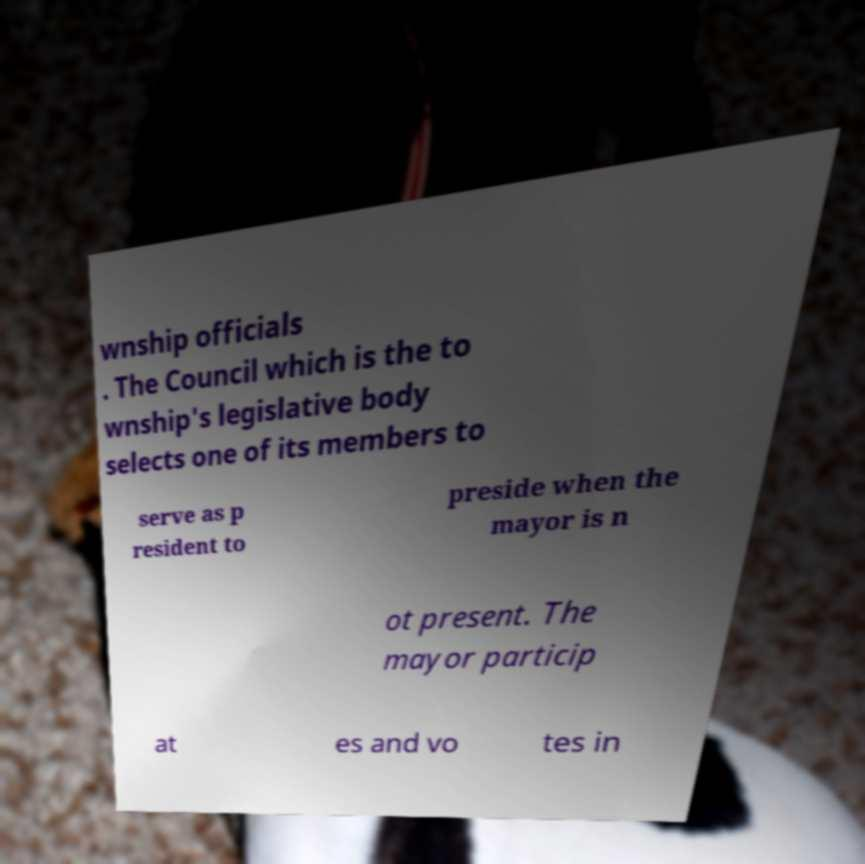Please identify and transcribe the text found in this image. wnship officials . The Council which is the to wnship's legislative body selects one of its members to serve as p resident to preside when the mayor is n ot present. The mayor particip at es and vo tes in 